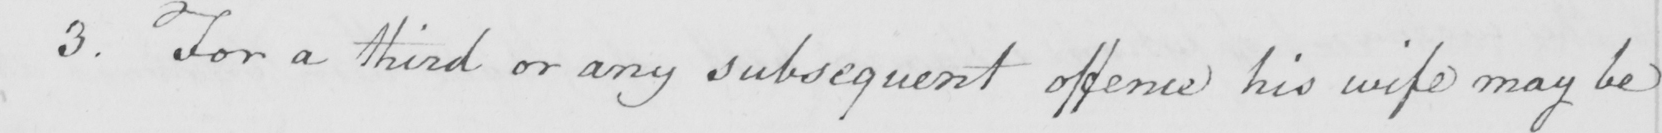Can you read and transcribe this handwriting? 3 . For a third or any subsequent offence his wife may be 